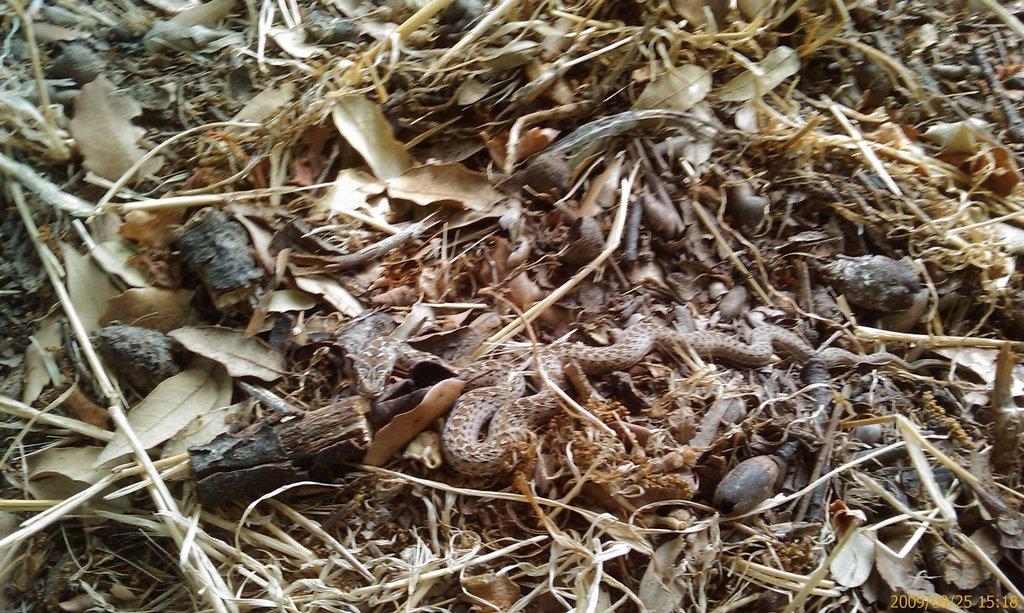What type of animal is in the image? There is a snake in the image. What can be seen at the bottom of the image? Dried leaves and wooden pieces are visible at the bottom of the image. What type of property does the snake's son own in the image? There is no mention of a son or property in the image; it only features a snake and dried leaves with wooden pieces. 